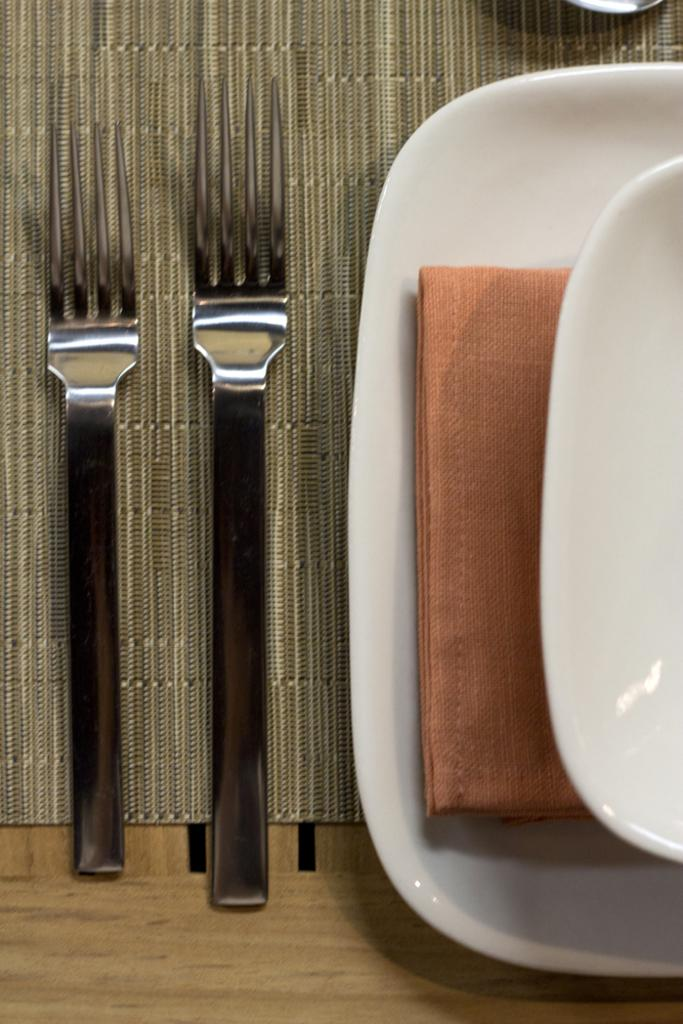What utensils are present in the image? There are forks in the image. What type of dishware is present in the image? There are plates in the image. Where are the forks and plates located? The forks and plates are placed on a table. What type of humor can be seen on the forks in the image? There is no humor present on the forks in the image; they are simply utensils. How many achievers can be seen using the forks in the image? There are no people or achievers present in the image, only forks and plates. 